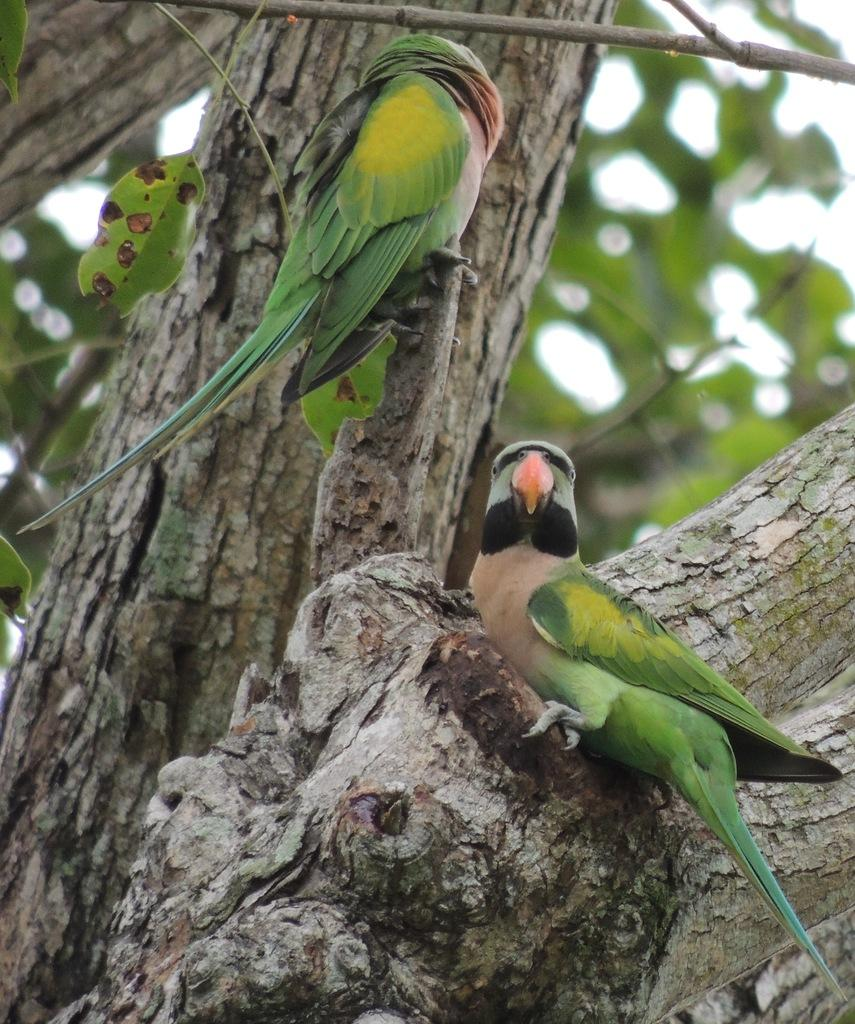What type of animals can be seen in the image? There are birds in the image. Where are the birds located in the image? The birds are on the branches of a tree. What can be seen in the background of the image? There are leaves in the background of the image. How many rings are hanging from the branches of the tree in the image? There are no rings present in the image; it features birds on the branches of a tree. What type of basket can be seen in the image? There is no basket present in the image. 